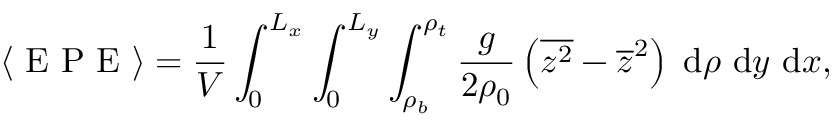Convert formula to latex. <formula><loc_0><loc_0><loc_500><loc_500>\langle E P E \rangle = \frac { 1 } { V } \int _ { 0 } ^ { L _ { x } } \int _ { 0 } ^ { L _ { y } } \int _ { \rho _ { b } } ^ { \rho _ { t } } \frac { g } { 2 \rho _ { 0 } } \left ( \overline { { z ^ { 2 } } } - \overline { z } ^ { 2 } \right ) \, d \rho \ d y \ d x ,</formula> 